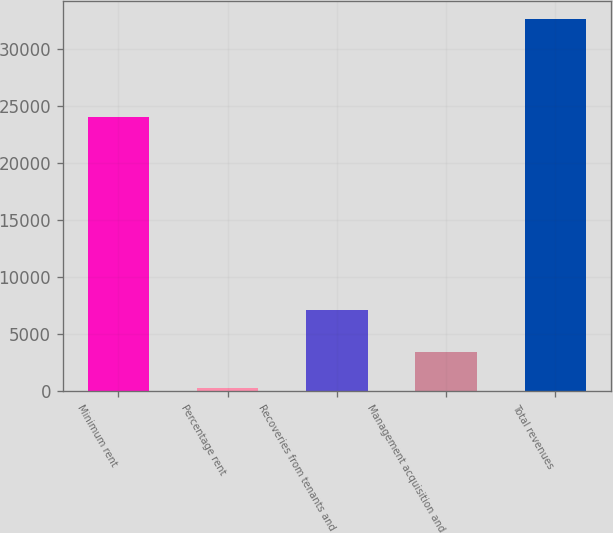<chart> <loc_0><loc_0><loc_500><loc_500><bar_chart><fcel>Minimum rent<fcel>Percentage rent<fcel>Recoveries from tenants and<fcel>Management acquisition and<fcel>Total revenues<nl><fcel>23969<fcel>231<fcel>7089<fcel>3462.7<fcel>32548<nl></chart> 